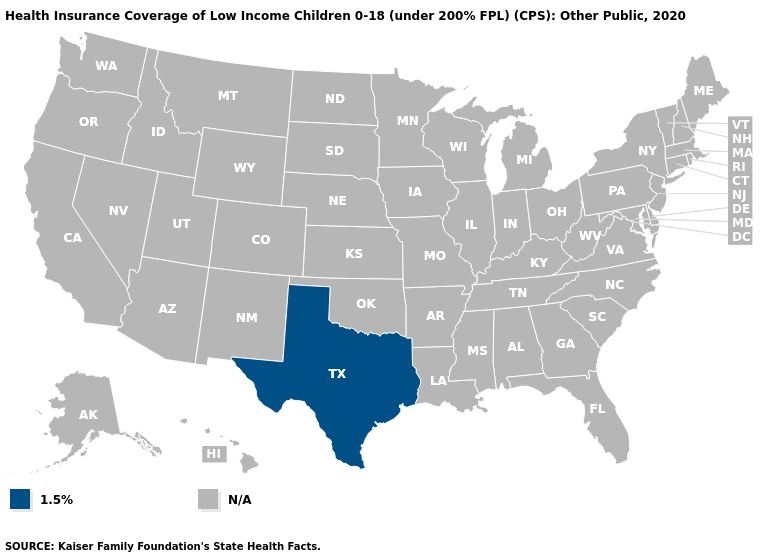Name the states that have a value in the range 1.5%?
Short answer required. Texas. Name the states that have a value in the range 1.5%?
Keep it brief. Texas. Does the map have missing data?
Answer briefly. Yes. What is the value of Florida?
Keep it brief. N/A. Which states have the lowest value in the USA?
Answer briefly. Texas. What is the value of Texas?
Concise answer only. 1.5%. How many symbols are there in the legend?
Write a very short answer. 2. Does the first symbol in the legend represent the smallest category?
Write a very short answer. Yes. How many symbols are there in the legend?
Answer briefly. 2. What is the value of New Jersey?
Answer briefly. N/A. Name the states that have a value in the range N/A?
Be succinct. Alabama, Alaska, Arizona, Arkansas, California, Colorado, Connecticut, Delaware, Florida, Georgia, Hawaii, Idaho, Illinois, Indiana, Iowa, Kansas, Kentucky, Louisiana, Maine, Maryland, Massachusetts, Michigan, Minnesota, Mississippi, Missouri, Montana, Nebraska, Nevada, New Hampshire, New Jersey, New Mexico, New York, North Carolina, North Dakota, Ohio, Oklahoma, Oregon, Pennsylvania, Rhode Island, South Carolina, South Dakota, Tennessee, Utah, Vermont, Virginia, Washington, West Virginia, Wisconsin, Wyoming. What is the value of Maine?
Give a very brief answer. N/A. Is the legend a continuous bar?
Keep it brief. No. 